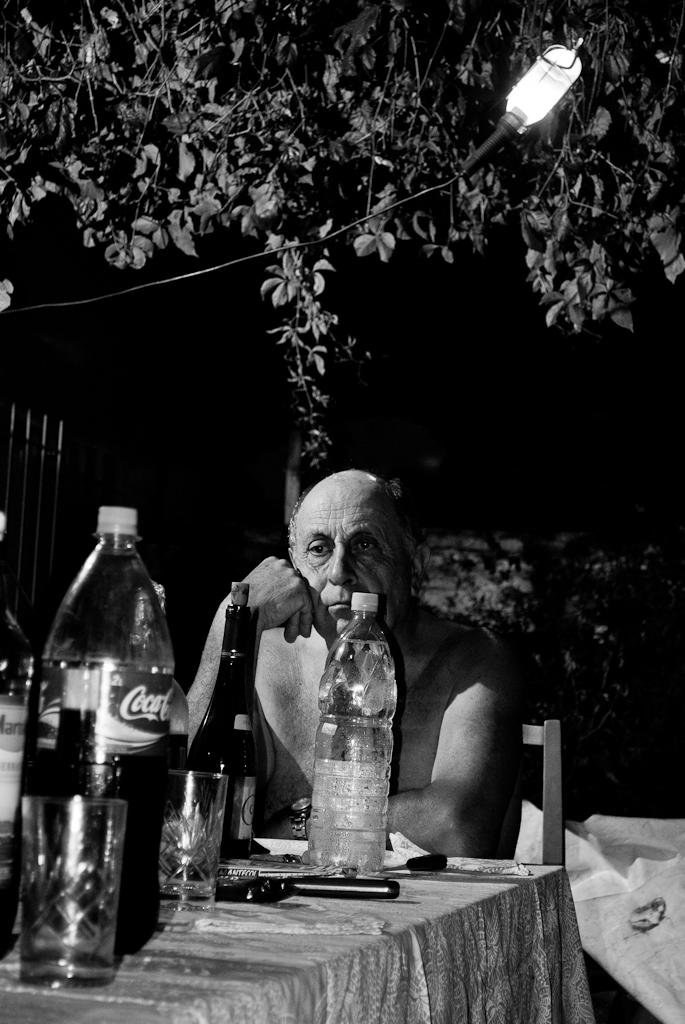<image>
Relay a brief, clear account of the picture shown. Man sitting at a desk behind a Coca Cola bottle. 